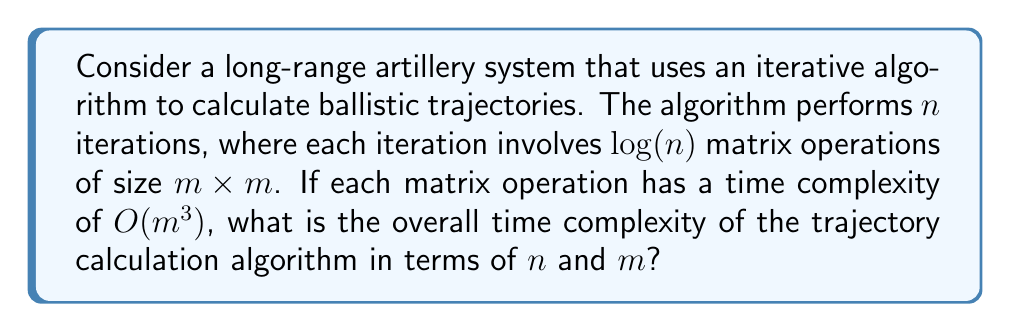What is the answer to this math problem? To determine the overall time complexity, we need to analyze the algorithm's structure and combine the complexities of its components:

1. The algorithm performs $n$ iterations.

2. In each iteration, there are $\log(n)$ matrix operations.

3. Each matrix operation has a time complexity of $O(m^3)$.

Let's break down the complexity calculation:

1. For a single iteration:
   - Number of matrix operations: $\log(n)$
   - Time for each matrix operation: $O(m^3)$
   - Time for one iteration: $O(\log(n) \cdot m^3)$

2. For all $n$ iterations:
   - Total time: $O(n \cdot \log(n) \cdot m^3)$

We can simplify this expression by combining the terms:

$$O(n \log(n) m^3)$$

This represents the overall time complexity of the trajectory calculation algorithm.

Note that this complexity shows that the algorithm's runtime grows:
- Linearithmically ($n \log(n)$) with respect to the number of iterations
- Cubically ($m^3$) with respect to the size of the matrices

For a military application, this means that increasing the accuracy (more iterations) or the complexity of the model (larger matrices) can significantly impact the computation time, which could be crucial in real-time combat situations.
Answer: $O(n \log(n) m^3)$ 